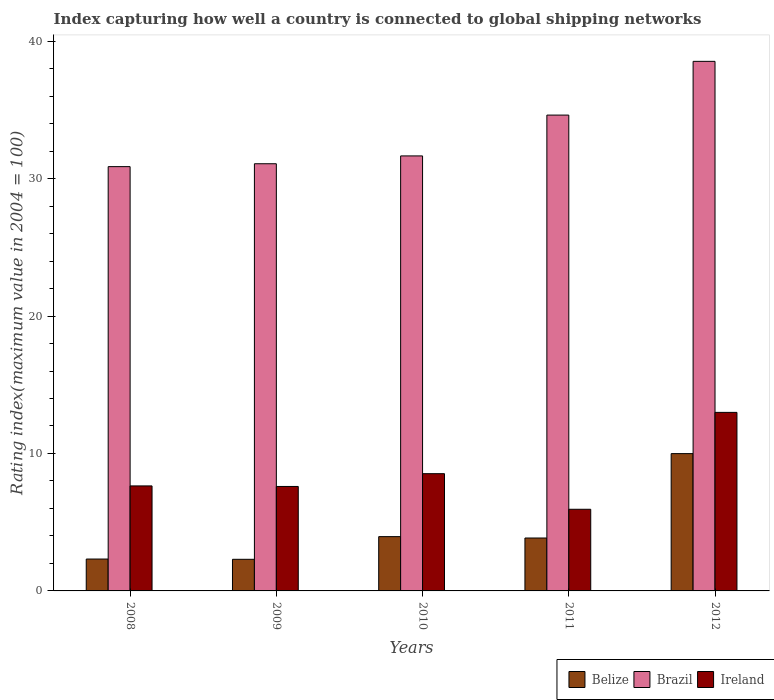Are the number of bars per tick equal to the number of legend labels?
Make the answer very short. Yes. Are the number of bars on each tick of the X-axis equal?
Keep it short and to the point. Yes. What is the label of the 2nd group of bars from the left?
Offer a very short reply. 2009. In how many cases, is the number of bars for a given year not equal to the number of legend labels?
Offer a terse response. 0. What is the rating index in Brazil in 2010?
Give a very brief answer. 31.65. Across all years, what is the maximum rating index in Brazil?
Provide a short and direct response. 38.53. Across all years, what is the minimum rating index in Ireland?
Give a very brief answer. 5.94. What is the total rating index in Belize in the graph?
Ensure brevity in your answer.  22.41. What is the difference between the rating index in Ireland in 2008 and that in 2011?
Offer a terse response. 1.7. What is the average rating index in Brazil per year?
Make the answer very short. 33.35. In the year 2008, what is the difference between the rating index in Belize and rating index in Ireland?
Provide a succinct answer. -5.32. In how many years, is the rating index in Brazil greater than 10?
Your response must be concise. 5. What is the ratio of the rating index in Ireland in 2008 to that in 2011?
Provide a succinct answer. 1.29. Is the difference between the rating index in Belize in 2008 and 2012 greater than the difference between the rating index in Ireland in 2008 and 2012?
Offer a very short reply. No. What is the difference between the highest and the second highest rating index in Brazil?
Provide a succinct answer. 3.91. What is the difference between the highest and the lowest rating index in Ireland?
Give a very brief answer. 7.05. What does the 3rd bar from the left in 2008 represents?
Offer a terse response. Ireland. What does the 1st bar from the right in 2009 represents?
Make the answer very short. Ireland. Is it the case that in every year, the sum of the rating index in Ireland and rating index in Belize is greater than the rating index in Brazil?
Your answer should be compact. No. How many bars are there?
Ensure brevity in your answer.  15. How many years are there in the graph?
Give a very brief answer. 5. What is the difference between two consecutive major ticks on the Y-axis?
Your answer should be very brief. 10. Does the graph contain any zero values?
Your response must be concise. No. Does the graph contain grids?
Provide a short and direct response. No. Where does the legend appear in the graph?
Make the answer very short. Bottom right. What is the title of the graph?
Offer a terse response. Index capturing how well a country is connected to global shipping networks. Does "Central African Republic" appear as one of the legend labels in the graph?
Offer a very short reply. No. What is the label or title of the X-axis?
Provide a short and direct response. Years. What is the label or title of the Y-axis?
Keep it short and to the point. Rating index(maximum value in 2004 = 100). What is the Rating index(maximum value in 2004 = 100) of Belize in 2008?
Keep it short and to the point. 2.32. What is the Rating index(maximum value in 2004 = 100) in Brazil in 2008?
Give a very brief answer. 30.87. What is the Rating index(maximum value in 2004 = 100) of Ireland in 2008?
Your answer should be very brief. 7.64. What is the Rating index(maximum value in 2004 = 100) of Belize in 2009?
Provide a succinct answer. 2.3. What is the Rating index(maximum value in 2004 = 100) in Brazil in 2009?
Provide a short and direct response. 31.08. What is the Rating index(maximum value in 2004 = 100) of Belize in 2010?
Your answer should be very brief. 3.95. What is the Rating index(maximum value in 2004 = 100) of Brazil in 2010?
Your response must be concise. 31.65. What is the Rating index(maximum value in 2004 = 100) in Ireland in 2010?
Your answer should be very brief. 8.53. What is the Rating index(maximum value in 2004 = 100) of Belize in 2011?
Provide a short and direct response. 3.85. What is the Rating index(maximum value in 2004 = 100) in Brazil in 2011?
Offer a terse response. 34.62. What is the Rating index(maximum value in 2004 = 100) of Ireland in 2011?
Your answer should be compact. 5.94. What is the Rating index(maximum value in 2004 = 100) of Belize in 2012?
Your response must be concise. 9.99. What is the Rating index(maximum value in 2004 = 100) in Brazil in 2012?
Offer a terse response. 38.53. What is the Rating index(maximum value in 2004 = 100) in Ireland in 2012?
Provide a short and direct response. 12.99. Across all years, what is the maximum Rating index(maximum value in 2004 = 100) in Belize?
Ensure brevity in your answer.  9.99. Across all years, what is the maximum Rating index(maximum value in 2004 = 100) in Brazil?
Keep it short and to the point. 38.53. Across all years, what is the maximum Rating index(maximum value in 2004 = 100) in Ireland?
Your answer should be very brief. 12.99. Across all years, what is the minimum Rating index(maximum value in 2004 = 100) of Brazil?
Offer a very short reply. 30.87. Across all years, what is the minimum Rating index(maximum value in 2004 = 100) of Ireland?
Your response must be concise. 5.94. What is the total Rating index(maximum value in 2004 = 100) in Belize in the graph?
Offer a very short reply. 22.41. What is the total Rating index(maximum value in 2004 = 100) in Brazil in the graph?
Your response must be concise. 166.75. What is the total Rating index(maximum value in 2004 = 100) of Ireland in the graph?
Keep it short and to the point. 42.7. What is the difference between the Rating index(maximum value in 2004 = 100) in Belize in 2008 and that in 2009?
Make the answer very short. 0.02. What is the difference between the Rating index(maximum value in 2004 = 100) in Brazil in 2008 and that in 2009?
Your answer should be very brief. -0.21. What is the difference between the Rating index(maximum value in 2004 = 100) of Belize in 2008 and that in 2010?
Your answer should be very brief. -1.63. What is the difference between the Rating index(maximum value in 2004 = 100) of Brazil in 2008 and that in 2010?
Offer a very short reply. -0.78. What is the difference between the Rating index(maximum value in 2004 = 100) of Ireland in 2008 and that in 2010?
Ensure brevity in your answer.  -0.89. What is the difference between the Rating index(maximum value in 2004 = 100) in Belize in 2008 and that in 2011?
Ensure brevity in your answer.  -1.53. What is the difference between the Rating index(maximum value in 2004 = 100) of Brazil in 2008 and that in 2011?
Offer a terse response. -3.75. What is the difference between the Rating index(maximum value in 2004 = 100) in Belize in 2008 and that in 2012?
Give a very brief answer. -7.67. What is the difference between the Rating index(maximum value in 2004 = 100) in Brazil in 2008 and that in 2012?
Your response must be concise. -7.66. What is the difference between the Rating index(maximum value in 2004 = 100) in Ireland in 2008 and that in 2012?
Your answer should be very brief. -5.35. What is the difference between the Rating index(maximum value in 2004 = 100) in Belize in 2009 and that in 2010?
Keep it short and to the point. -1.65. What is the difference between the Rating index(maximum value in 2004 = 100) in Brazil in 2009 and that in 2010?
Make the answer very short. -0.57. What is the difference between the Rating index(maximum value in 2004 = 100) in Ireland in 2009 and that in 2010?
Give a very brief answer. -0.93. What is the difference between the Rating index(maximum value in 2004 = 100) of Belize in 2009 and that in 2011?
Your answer should be very brief. -1.55. What is the difference between the Rating index(maximum value in 2004 = 100) in Brazil in 2009 and that in 2011?
Offer a terse response. -3.54. What is the difference between the Rating index(maximum value in 2004 = 100) of Ireland in 2009 and that in 2011?
Your response must be concise. 1.66. What is the difference between the Rating index(maximum value in 2004 = 100) of Belize in 2009 and that in 2012?
Offer a terse response. -7.69. What is the difference between the Rating index(maximum value in 2004 = 100) in Brazil in 2009 and that in 2012?
Keep it short and to the point. -7.45. What is the difference between the Rating index(maximum value in 2004 = 100) in Ireland in 2009 and that in 2012?
Give a very brief answer. -5.39. What is the difference between the Rating index(maximum value in 2004 = 100) of Brazil in 2010 and that in 2011?
Give a very brief answer. -2.97. What is the difference between the Rating index(maximum value in 2004 = 100) in Ireland in 2010 and that in 2011?
Provide a succinct answer. 2.59. What is the difference between the Rating index(maximum value in 2004 = 100) of Belize in 2010 and that in 2012?
Make the answer very short. -6.04. What is the difference between the Rating index(maximum value in 2004 = 100) of Brazil in 2010 and that in 2012?
Your response must be concise. -6.88. What is the difference between the Rating index(maximum value in 2004 = 100) in Ireland in 2010 and that in 2012?
Ensure brevity in your answer.  -4.46. What is the difference between the Rating index(maximum value in 2004 = 100) of Belize in 2011 and that in 2012?
Provide a short and direct response. -6.14. What is the difference between the Rating index(maximum value in 2004 = 100) of Brazil in 2011 and that in 2012?
Your response must be concise. -3.91. What is the difference between the Rating index(maximum value in 2004 = 100) in Ireland in 2011 and that in 2012?
Your answer should be compact. -7.05. What is the difference between the Rating index(maximum value in 2004 = 100) in Belize in 2008 and the Rating index(maximum value in 2004 = 100) in Brazil in 2009?
Offer a terse response. -28.76. What is the difference between the Rating index(maximum value in 2004 = 100) of Belize in 2008 and the Rating index(maximum value in 2004 = 100) of Ireland in 2009?
Provide a succinct answer. -5.28. What is the difference between the Rating index(maximum value in 2004 = 100) in Brazil in 2008 and the Rating index(maximum value in 2004 = 100) in Ireland in 2009?
Your answer should be very brief. 23.27. What is the difference between the Rating index(maximum value in 2004 = 100) of Belize in 2008 and the Rating index(maximum value in 2004 = 100) of Brazil in 2010?
Provide a short and direct response. -29.33. What is the difference between the Rating index(maximum value in 2004 = 100) of Belize in 2008 and the Rating index(maximum value in 2004 = 100) of Ireland in 2010?
Give a very brief answer. -6.21. What is the difference between the Rating index(maximum value in 2004 = 100) of Brazil in 2008 and the Rating index(maximum value in 2004 = 100) of Ireland in 2010?
Give a very brief answer. 22.34. What is the difference between the Rating index(maximum value in 2004 = 100) of Belize in 2008 and the Rating index(maximum value in 2004 = 100) of Brazil in 2011?
Provide a short and direct response. -32.3. What is the difference between the Rating index(maximum value in 2004 = 100) in Belize in 2008 and the Rating index(maximum value in 2004 = 100) in Ireland in 2011?
Offer a terse response. -3.62. What is the difference between the Rating index(maximum value in 2004 = 100) of Brazil in 2008 and the Rating index(maximum value in 2004 = 100) of Ireland in 2011?
Provide a succinct answer. 24.93. What is the difference between the Rating index(maximum value in 2004 = 100) of Belize in 2008 and the Rating index(maximum value in 2004 = 100) of Brazil in 2012?
Provide a succinct answer. -36.21. What is the difference between the Rating index(maximum value in 2004 = 100) of Belize in 2008 and the Rating index(maximum value in 2004 = 100) of Ireland in 2012?
Keep it short and to the point. -10.67. What is the difference between the Rating index(maximum value in 2004 = 100) in Brazil in 2008 and the Rating index(maximum value in 2004 = 100) in Ireland in 2012?
Offer a terse response. 17.88. What is the difference between the Rating index(maximum value in 2004 = 100) in Belize in 2009 and the Rating index(maximum value in 2004 = 100) in Brazil in 2010?
Offer a very short reply. -29.35. What is the difference between the Rating index(maximum value in 2004 = 100) in Belize in 2009 and the Rating index(maximum value in 2004 = 100) in Ireland in 2010?
Offer a very short reply. -6.23. What is the difference between the Rating index(maximum value in 2004 = 100) in Brazil in 2009 and the Rating index(maximum value in 2004 = 100) in Ireland in 2010?
Offer a terse response. 22.55. What is the difference between the Rating index(maximum value in 2004 = 100) of Belize in 2009 and the Rating index(maximum value in 2004 = 100) of Brazil in 2011?
Your answer should be compact. -32.32. What is the difference between the Rating index(maximum value in 2004 = 100) of Belize in 2009 and the Rating index(maximum value in 2004 = 100) of Ireland in 2011?
Keep it short and to the point. -3.64. What is the difference between the Rating index(maximum value in 2004 = 100) of Brazil in 2009 and the Rating index(maximum value in 2004 = 100) of Ireland in 2011?
Your answer should be compact. 25.14. What is the difference between the Rating index(maximum value in 2004 = 100) in Belize in 2009 and the Rating index(maximum value in 2004 = 100) in Brazil in 2012?
Ensure brevity in your answer.  -36.23. What is the difference between the Rating index(maximum value in 2004 = 100) in Belize in 2009 and the Rating index(maximum value in 2004 = 100) in Ireland in 2012?
Make the answer very short. -10.69. What is the difference between the Rating index(maximum value in 2004 = 100) of Brazil in 2009 and the Rating index(maximum value in 2004 = 100) of Ireland in 2012?
Your answer should be compact. 18.09. What is the difference between the Rating index(maximum value in 2004 = 100) of Belize in 2010 and the Rating index(maximum value in 2004 = 100) of Brazil in 2011?
Your response must be concise. -30.67. What is the difference between the Rating index(maximum value in 2004 = 100) of Belize in 2010 and the Rating index(maximum value in 2004 = 100) of Ireland in 2011?
Your response must be concise. -1.99. What is the difference between the Rating index(maximum value in 2004 = 100) of Brazil in 2010 and the Rating index(maximum value in 2004 = 100) of Ireland in 2011?
Keep it short and to the point. 25.71. What is the difference between the Rating index(maximum value in 2004 = 100) in Belize in 2010 and the Rating index(maximum value in 2004 = 100) in Brazil in 2012?
Keep it short and to the point. -34.58. What is the difference between the Rating index(maximum value in 2004 = 100) of Belize in 2010 and the Rating index(maximum value in 2004 = 100) of Ireland in 2012?
Your response must be concise. -9.04. What is the difference between the Rating index(maximum value in 2004 = 100) in Brazil in 2010 and the Rating index(maximum value in 2004 = 100) in Ireland in 2012?
Offer a terse response. 18.66. What is the difference between the Rating index(maximum value in 2004 = 100) of Belize in 2011 and the Rating index(maximum value in 2004 = 100) of Brazil in 2012?
Your answer should be very brief. -34.68. What is the difference between the Rating index(maximum value in 2004 = 100) in Belize in 2011 and the Rating index(maximum value in 2004 = 100) in Ireland in 2012?
Give a very brief answer. -9.14. What is the difference between the Rating index(maximum value in 2004 = 100) in Brazil in 2011 and the Rating index(maximum value in 2004 = 100) in Ireland in 2012?
Provide a succinct answer. 21.63. What is the average Rating index(maximum value in 2004 = 100) in Belize per year?
Provide a short and direct response. 4.48. What is the average Rating index(maximum value in 2004 = 100) in Brazil per year?
Your response must be concise. 33.35. What is the average Rating index(maximum value in 2004 = 100) of Ireland per year?
Keep it short and to the point. 8.54. In the year 2008, what is the difference between the Rating index(maximum value in 2004 = 100) in Belize and Rating index(maximum value in 2004 = 100) in Brazil?
Provide a succinct answer. -28.55. In the year 2008, what is the difference between the Rating index(maximum value in 2004 = 100) in Belize and Rating index(maximum value in 2004 = 100) in Ireland?
Ensure brevity in your answer.  -5.32. In the year 2008, what is the difference between the Rating index(maximum value in 2004 = 100) of Brazil and Rating index(maximum value in 2004 = 100) of Ireland?
Provide a short and direct response. 23.23. In the year 2009, what is the difference between the Rating index(maximum value in 2004 = 100) of Belize and Rating index(maximum value in 2004 = 100) of Brazil?
Give a very brief answer. -28.78. In the year 2009, what is the difference between the Rating index(maximum value in 2004 = 100) in Belize and Rating index(maximum value in 2004 = 100) in Ireland?
Provide a short and direct response. -5.3. In the year 2009, what is the difference between the Rating index(maximum value in 2004 = 100) of Brazil and Rating index(maximum value in 2004 = 100) of Ireland?
Keep it short and to the point. 23.48. In the year 2010, what is the difference between the Rating index(maximum value in 2004 = 100) of Belize and Rating index(maximum value in 2004 = 100) of Brazil?
Keep it short and to the point. -27.7. In the year 2010, what is the difference between the Rating index(maximum value in 2004 = 100) of Belize and Rating index(maximum value in 2004 = 100) of Ireland?
Your answer should be compact. -4.58. In the year 2010, what is the difference between the Rating index(maximum value in 2004 = 100) in Brazil and Rating index(maximum value in 2004 = 100) in Ireland?
Provide a short and direct response. 23.12. In the year 2011, what is the difference between the Rating index(maximum value in 2004 = 100) of Belize and Rating index(maximum value in 2004 = 100) of Brazil?
Your answer should be compact. -30.77. In the year 2011, what is the difference between the Rating index(maximum value in 2004 = 100) of Belize and Rating index(maximum value in 2004 = 100) of Ireland?
Make the answer very short. -2.09. In the year 2011, what is the difference between the Rating index(maximum value in 2004 = 100) in Brazil and Rating index(maximum value in 2004 = 100) in Ireland?
Your answer should be very brief. 28.68. In the year 2012, what is the difference between the Rating index(maximum value in 2004 = 100) of Belize and Rating index(maximum value in 2004 = 100) of Brazil?
Offer a very short reply. -28.54. In the year 2012, what is the difference between the Rating index(maximum value in 2004 = 100) of Belize and Rating index(maximum value in 2004 = 100) of Ireland?
Your response must be concise. -3. In the year 2012, what is the difference between the Rating index(maximum value in 2004 = 100) in Brazil and Rating index(maximum value in 2004 = 100) in Ireland?
Your response must be concise. 25.54. What is the ratio of the Rating index(maximum value in 2004 = 100) of Belize in 2008 to that in 2009?
Offer a very short reply. 1.01. What is the ratio of the Rating index(maximum value in 2004 = 100) of Brazil in 2008 to that in 2009?
Make the answer very short. 0.99. What is the ratio of the Rating index(maximum value in 2004 = 100) in Ireland in 2008 to that in 2009?
Provide a succinct answer. 1.01. What is the ratio of the Rating index(maximum value in 2004 = 100) in Belize in 2008 to that in 2010?
Your answer should be very brief. 0.59. What is the ratio of the Rating index(maximum value in 2004 = 100) in Brazil in 2008 to that in 2010?
Your answer should be compact. 0.98. What is the ratio of the Rating index(maximum value in 2004 = 100) in Ireland in 2008 to that in 2010?
Keep it short and to the point. 0.9. What is the ratio of the Rating index(maximum value in 2004 = 100) of Belize in 2008 to that in 2011?
Ensure brevity in your answer.  0.6. What is the ratio of the Rating index(maximum value in 2004 = 100) of Brazil in 2008 to that in 2011?
Offer a very short reply. 0.89. What is the ratio of the Rating index(maximum value in 2004 = 100) in Ireland in 2008 to that in 2011?
Give a very brief answer. 1.29. What is the ratio of the Rating index(maximum value in 2004 = 100) in Belize in 2008 to that in 2012?
Keep it short and to the point. 0.23. What is the ratio of the Rating index(maximum value in 2004 = 100) in Brazil in 2008 to that in 2012?
Offer a terse response. 0.8. What is the ratio of the Rating index(maximum value in 2004 = 100) of Ireland in 2008 to that in 2012?
Ensure brevity in your answer.  0.59. What is the ratio of the Rating index(maximum value in 2004 = 100) of Belize in 2009 to that in 2010?
Keep it short and to the point. 0.58. What is the ratio of the Rating index(maximum value in 2004 = 100) of Brazil in 2009 to that in 2010?
Your response must be concise. 0.98. What is the ratio of the Rating index(maximum value in 2004 = 100) in Ireland in 2009 to that in 2010?
Your response must be concise. 0.89. What is the ratio of the Rating index(maximum value in 2004 = 100) in Belize in 2009 to that in 2011?
Ensure brevity in your answer.  0.6. What is the ratio of the Rating index(maximum value in 2004 = 100) of Brazil in 2009 to that in 2011?
Ensure brevity in your answer.  0.9. What is the ratio of the Rating index(maximum value in 2004 = 100) in Ireland in 2009 to that in 2011?
Offer a very short reply. 1.28. What is the ratio of the Rating index(maximum value in 2004 = 100) in Belize in 2009 to that in 2012?
Your answer should be compact. 0.23. What is the ratio of the Rating index(maximum value in 2004 = 100) in Brazil in 2009 to that in 2012?
Keep it short and to the point. 0.81. What is the ratio of the Rating index(maximum value in 2004 = 100) of Ireland in 2009 to that in 2012?
Your answer should be compact. 0.59. What is the ratio of the Rating index(maximum value in 2004 = 100) of Brazil in 2010 to that in 2011?
Offer a terse response. 0.91. What is the ratio of the Rating index(maximum value in 2004 = 100) of Ireland in 2010 to that in 2011?
Offer a terse response. 1.44. What is the ratio of the Rating index(maximum value in 2004 = 100) of Belize in 2010 to that in 2012?
Offer a terse response. 0.4. What is the ratio of the Rating index(maximum value in 2004 = 100) of Brazil in 2010 to that in 2012?
Provide a succinct answer. 0.82. What is the ratio of the Rating index(maximum value in 2004 = 100) of Ireland in 2010 to that in 2012?
Keep it short and to the point. 0.66. What is the ratio of the Rating index(maximum value in 2004 = 100) in Belize in 2011 to that in 2012?
Ensure brevity in your answer.  0.39. What is the ratio of the Rating index(maximum value in 2004 = 100) of Brazil in 2011 to that in 2012?
Your answer should be compact. 0.9. What is the ratio of the Rating index(maximum value in 2004 = 100) of Ireland in 2011 to that in 2012?
Provide a short and direct response. 0.46. What is the difference between the highest and the second highest Rating index(maximum value in 2004 = 100) of Belize?
Your response must be concise. 6.04. What is the difference between the highest and the second highest Rating index(maximum value in 2004 = 100) of Brazil?
Your answer should be very brief. 3.91. What is the difference between the highest and the second highest Rating index(maximum value in 2004 = 100) of Ireland?
Keep it short and to the point. 4.46. What is the difference between the highest and the lowest Rating index(maximum value in 2004 = 100) of Belize?
Ensure brevity in your answer.  7.69. What is the difference between the highest and the lowest Rating index(maximum value in 2004 = 100) of Brazil?
Offer a very short reply. 7.66. What is the difference between the highest and the lowest Rating index(maximum value in 2004 = 100) in Ireland?
Give a very brief answer. 7.05. 